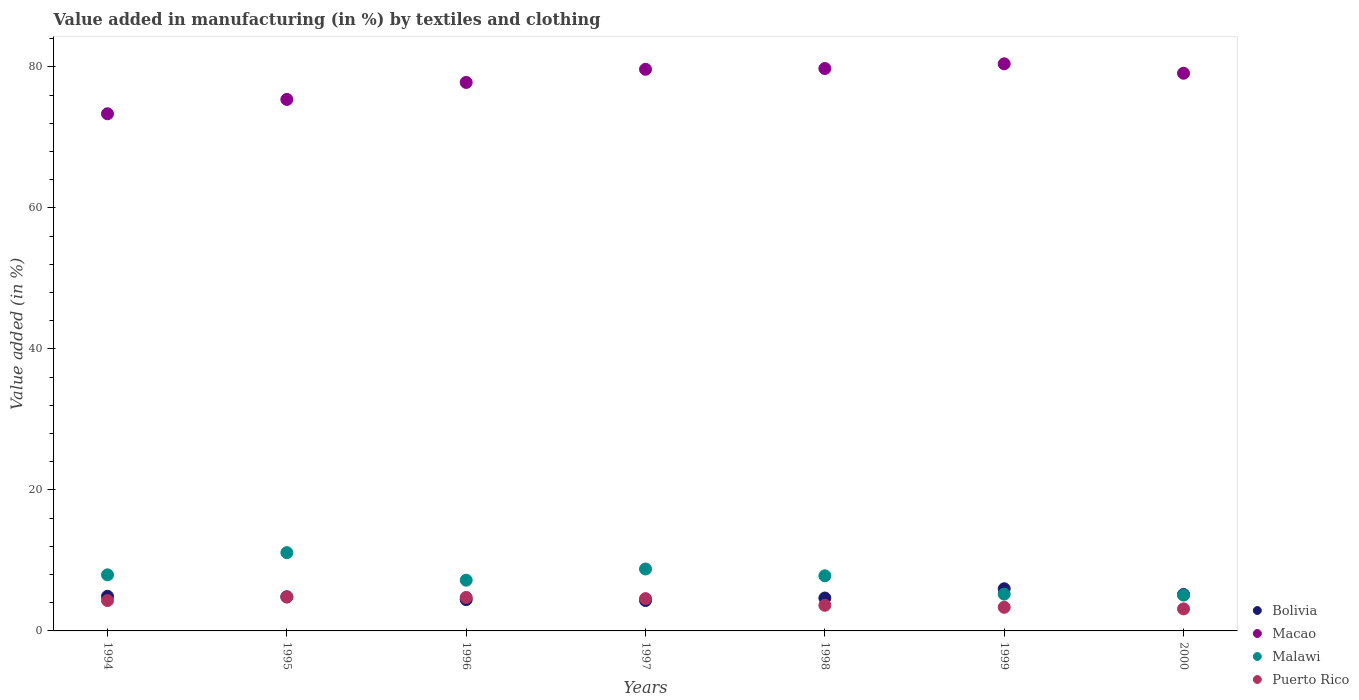How many different coloured dotlines are there?
Give a very brief answer. 4. Is the number of dotlines equal to the number of legend labels?
Provide a succinct answer. Yes. What is the percentage of value added in manufacturing by textiles and clothing in Puerto Rico in 2000?
Ensure brevity in your answer.  3.13. Across all years, what is the maximum percentage of value added in manufacturing by textiles and clothing in Malawi?
Your response must be concise. 11.1. Across all years, what is the minimum percentage of value added in manufacturing by textiles and clothing in Macao?
Your answer should be compact. 73.35. In which year was the percentage of value added in manufacturing by textiles and clothing in Puerto Rico maximum?
Your answer should be compact. 1995. In which year was the percentage of value added in manufacturing by textiles and clothing in Malawi minimum?
Offer a very short reply. 2000. What is the total percentage of value added in manufacturing by textiles and clothing in Malawi in the graph?
Ensure brevity in your answer.  53.15. What is the difference between the percentage of value added in manufacturing by textiles and clothing in Bolivia in 1997 and that in 1998?
Your answer should be very brief. -0.35. What is the difference between the percentage of value added in manufacturing by textiles and clothing in Puerto Rico in 1998 and the percentage of value added in manufacturing by textiles and clothing in Bolivia in 1994?
Ensure brevity in your answer.  -1.27. What is the average percentage of value added in manufacturing by textiles and clothing in Puerto Rico per year?
Offer a terse response. 4.08. In the year 1998, what is the difference between the percentage of value added in manufacturing by textiles and clothing in Puerto Rico and percentage of value added in manufacturing by textiles and clothing in Macao?
Offer a very short reply. -76.14. In how many years, is the percentage of value added in manufacturing by textiles and clothing in Malawi greater than 44 %?
Your answer should be very brief. 0. What is the ratio of the percentage of value added in manufacturing by textiles and clothing in Malawi in 1997 to that in 1998?
Your answer should be compact. 1.12. What is the difference between the highest and the second highest percentage of value added in manufacturing by textiles and clothing in Bolivia?
Offer a terse response. 0.81. What is the difference between the highest and the lowest percentage of value added in manufacturing by textiles and clothing in Macao?
Offer a very short reply. 7.08. In how many years, is the percentage of value added in manufacturing by textiles and clothing in Bolivia greater than the average percentage of value added in manufacturing by textiles and clothing in Bolivia taken over all years?
Give a very brief answer. 3. Is the sum of the percentage of value added in manufacturing by textiles and clothing in Malawi in 1994 and 1998 greater than the maximum percentage of value added in manufacturing by textiles and clothing in Bolivia across all years?
Your response must be concise. Yes. Is the percentage of value added in manufacturing by textiles and clothing in Macao strictly less than the percentage of value added in manufacturing by textiles and clothing in Malawi over the years?
Your response must be concise. No. How many dotlines are there?
Ensure brevity in your answer.  4. Are the values on the major ticks of Y-axis written in scientific E-notation?
Your answer should be very brief. No. How are the legend labels stacked?
Make the answer very short. Vertical. What is the title of the graph?
Your response must be concise. Value added in manufacturing (in %) by textiles and clothing. What is the label or title of the Y-axis?
Your response must be concise. Value added (in %). What is the Value added (in %) in Bolivia in 1994?
Offer a terse response. 4.91. What is the Value added (in %) in Macao in 1994?
Your answer should be very brief. 73.35. What is the Value added (in %) of Malawi in 1994?
Provide a short and direct response. 7.95. What is the Value added (in %) of Puerto Rico in 1994?
Your answer should be compact. 4.31. What is the Value added (in %) of Bolivia in 1995?
Your answer should be compact. 4.84. What is the Value added (in %) in Macao in 1995?
Offer a very short reply. 75.38. What is the Value added (in %) in Malawi in 1995?
Make the answer very short. 11.1. What is the Value added (in %) in Puerto Rico in 1995?
Your answer should be very brief. 4.8. What is the Value added (in %) in Bolivia in 1996?
Provide a succinct answer. 4.44. What is the Value added (in %) in Macao in 1996?
Your response must be concise. 77.8. What is the Value added (in %) in Malawi in 1996?
Offer a terse response. 7.19. What is the Value added (in %) of Puerto Rico in 1996?
Offer a very short reply. 4.75. What is the Value added (in %) of Bolivia in 1997?
Offer a terse response. 4.31. What is the Value added (in %) of Macao in 1997?
Your response must be concise. 79.66. What is the Value added (in %) in Malawi in 1997?
Provide a short and direct response. 8.78. What is the Value added (in %) of Puerto Rico in 1997?
Your response must be concise. 4.58. What is the Value added (in %) in Bolivia in 1998?
Your response must be concise. 4.67. What is the Value added (in %) in Macao in 1998?
Make the answer very short. 79.77. What is the Value added (in %) in Malawi in 1998?
Offer a very short reply. 7.82. What is the Value added (in %) of Puerto Rico in 1998?
Your answer should be compact. 3.63. What is the Value added (in %) in Bolivia in 1999?
Provide a succinct answer. 5.98. What is the Value added (in %) in Macao in 1999?
Provide a succinct answer. 80.43. What is the Value added (in %) in Malawi in 1999?
Offer a terse response. 5.22. What is the Value added (in %) of Puerto Rico in 1999?
Offer a terse response. 3.35. What is the Value added (in %) in Bolivia in 2000?
Keep it short and to the point. 5.17. What is the Value added (in %) of Macao in 2000?
Offer a terse response. 79.1. What is the Value added (in %) of Malawi in 2000?
Offer a terse response. 5.08. What is the Value added (in %) in Puerto Rico in 2000?
Ensure brevity in your answer.  3.13. Across all years, what is the maximum Value added (in %) of Bolivia?
Ensure brevity in your answer.  5.98. Across all years, what is the maximum Value added (in %) of Macao?
Offer a very short reply. 80.43. Across all years, what is the maximum Value added (in %) in Malawi?
Offer a very short reply. 11.1. Across all years, what is the maximum Value added (in %) of Puerto Rico?
Keep it short and to the point. 4.8. Across all years, what is the minimum Value added (in %) of Bolivia?
Provide a succinct answer. 4.31. Across all years, what is the minimum Value added (in %) of Macao?
Make the answer very short. 73.35. Across all years, what is the minimum Value added (in %) in Malawi?
Offer a terse response. 5.08. Across all years, what is the minimum Value added (in %) in Puerto Rico?
Make the answer very short. 3.13. What is the total Value added (in %) of Bolivia in the graph?
Your response must be concise. 34.32. What is the total Value added (in %) in Macao in the graph?
Keep it short and to the point. 545.49. What is the total Value added (in %) of Malawi in the graph?
Your answer should be compact. 53.15. What is the total Value added (in %) of Puerto Rico in the graph?
Ensure brevity in your answer.  28.55. What is the difference between the Value added (in %) of Bolivia in 1994 and that in 1995?
Give a very brief answer. 0.06. What is the difference between the Value added (in %) of Macao in 1994 and that in 1995?
Give a very brief answer. -2.03. What is the difference between the Value added (in %) of Malawi in 1994 and that in 1995?
Keep it short and to the point. -3.15. What is the difference between the Value added (in %) of Puerto Rico in 1994 and that in 1995?
Give a very brief answer. -0.5. What is the difference between the Value added (in %) in Bolivia in 1994 and that in 1996?
Your answer should be compact. 0.47. What is the difference between the Value added (in %) of Macao in 1994 and that in 1996?
Offer a terse response. -4.45. What is the difference between the Value added (in %) in Malawi in 1994 and that in 1996?
Offer a very short reply. 0.76. What is the difference between the Value added (in %) of Puerto Rico in 1994 and that in 1996?
Provide a succinct answer. -0.44. What is the difference between the Value added (in %) of Bolivia in 1994 and that in 1997?
Your answer should be compact. 0.6. What is the difference between the Value added (in %) in Macao in 1994 and that in 1997?
Give a very brief answer. -6.31. What is the difference between the Value added (in %) of Malawi in 1994 and that in 1997?
Offer a very short reply. -0.83. What is the difference between the Value added (in %) of Puerto Rico in 1994 and that in 1997?
Make the answer very short. -0.28. What is the difference between the Value added (in %) in Bolivia in 1994 and that in 1998?
Offer a terse response. 0.24. What is the difference between the Value added (in %) in Macao in 1994 and that in 1998?
Offer a terse response. -6.42. What is the difference between the Value added (in %) in Malawi in 1994 and that in 1998?
Keep it short and to the point. 0.14. What is the difference between the Value added (in %) of Puerto Rico in 1994 and that in 1998?
Your answer should be compact. 0.67. What is the difference between the Value added (in %) of Bolivia in 1994 and that in 1999?
Offer a terse response. -1.07. What is the difference between the Value added (in %) in Macao in 1994 and that in 1999?
Ensure brevity in your answer.  -7.08. What is the difference between the Value added (in %) in Malawi in 1994 and that in 1999?
Make the answer very short. 2.74. What is the difference between the Value added (in %) in Puerto Rico in 1994 and that in 1999?
Offer a terse response. 0.96. What is the difference between the Value added (in %) in Bolivia in 1994 and that in 2000?
Your response must be concise. -0.26. What is the difference between the Value added (in %) of Macao in 1994 and that in 2000?
Your answer should be very brief. -5.75. What is the difference between the Value added (in %) in Malawi in 1994 and that in 2000?
Provide a succinct answer. 2.87. What is the difference between the Value added (in %) in Puerto Rico in 1994 and that in 2000?
Your response must be concise. 1.18. What is the difference between the Value added (in %) in Bolivia in 1995 and that in 1996?
Ensure brevity in your answer.  0.41. What is the difference between the Value added (in %) of Macao in 1995 and that in 1996?
Give a very brief answer. -2.41. What is the difference between the Value added (in %) of Malawi in 1995 and that in 1996?
Offer a very short reply. 3.91. What is the difference between the Value added (in %) in Puerto Rico in 1995 and that in 1996?
Your answer should be very brief. 0.06. What is the difference between the Value added (in %) of Bolivia in 1995 and that in 1997?
Your answer should be compact. 0.53. What is the difference between the Value added (in %) of Macao in 1995 and that in 1997?
Provide a succinct answer. -4.27. What is the difference between the Value added (in %) in Malawi in 1995 and that in 1997?
Provide a succinct answer. 2.32. What is the difference between the Value added (in %) of Puerto Rico in 1995 and that in 1997?
Your answer should be very brief. 0.22. What is the difference between the Value added (in %) in Bolivia in 1995 and that in 1998?
Your answer should be very brief. 0.18. What is the difference between the Value added (in %) of Macao in 1995 and that in 1998?
Ensure brevity in your answer.  -4.39. What is the difference between the Value added (in %) in Malawi in 1995 and that in 1998?
Make the answer very short. 3.28. What is the difference between the Value added (in %) of Puerto Rico in 1995 and that in 1998?
Your answer should be compact. 1.17. What is the difference between the Value added (in %) in Bolivia in 1995 and that in 1999?
Provide a short and direct response. -1.14. What is the difference between the Value added (in %) of Macao in 1995 and that in 1999?
Offer a very short reply. -5.05. What is the difference between the Value added (in %) of Malawi in 1995 and that in 1999?
Your answer should be very brief. 5.88. What is the difference between the Value added (in %) of Puerto Rico in 1995 and that in 1999?
Ensure brevity in your answer.  1.46. What is the difference between the Value added (in %) of Bolivia in 1995 and that in 2000?
Offer a very short reply. -0.33. What is the difference between the Value added (in %) of Macao in 1995 and that in 2000?
Your answer should be very brief. -3.71. What is the difference between the Value added (in %) in Malawi in 1995 and that in 2000?
Provide a short and direct response. 6.02. What is the difference between the Value added (in %) in Puerto Rico in 1995 and that in 2000?
Ensure brevity in your answer.  1.68. What is the difference between the Value added (in %) of Bolivia in 1996 and that in 1997?
Provide a short and direct response. 0.12. What is the difference between the Value added (in %) in Macao in 1996 and that in 1997?
Keep it short and to the point. -1.86. What is the difference between the Value added (in %) in Malawi in 1996 and that in 1997?
Offer a terse response. -1.59. What is the difference between the Value added (in %) in Puerto Rico in 1996 and that in 1997?
Provide a short and direct response. 0.17. What is the difference between the Value added (in %) of Bolivia in 1996 and that in 1998?
Make the answer very short. -0.23. What is the difference between the Value added (in %) in Macao in 1996 and that in 1998?
Make the answer very short. -1.97. What is the difference between the Value added (in %) of Malawi in 1996 and that in 1998?
Your answer should be compact. -0.62. What is the difference between the Value added (in %) in Puerto Rico in 1996 and that in 1998?
Your answer should be very brief. 1.11. What is the difference between the Value added (in %) in Bolivia in 1996 and that in 1999?
Provide a succinct answer. -1.54. What is the difference between the Value added (in %) in Macao in 1996 and that in 1999?
Your answer should be very brief. -2.64. What is the difference between the Value added (in %) in Malawi in 1996 and that in 1999?
Your response must be concise. 1.98. What is the difference between the Value added (in %) of Puerto Rico in 1996 and that in 1999?
Your response must be concise. 1.4. What is the difference between the Value added (in %) in Bolivia in 1996 and that in 2000?
Make the answer very short. -0.74. What is the difference between the Value added (in %) in Macao in 1996 and that in 2000?
Offer a very short reply. -1.3. What is the difference between the Value added (in %) in Malawi in 1996 and that in 2000?
Offer a terse response. 2.11. What is the difference between the Value added (in %) of Puerto Rico in 1996 and that in 2000?
Keep it short and to the point. 1.62. What is the difference between the Value added (in %) of Bolivia in 1997 and that in 1998?
Your answer should be very brief. -0.35. What is the difference between the Value added (in %) of Macao in 1997 and that in 1998?
Give a very brief answer. -0.11. What is the difference between the Value added (in %) of Malawi in 1997 and that in 1998?
Provide a short and direct response. 0.97. What is the difference between the Value added (in %) of Puerto Rico in 1997 and that in 1998?
Offer a terse response. 0.95. What is the difference between the Value added (in %) in Bolivia in 1997 and that in 1999?
Your response must be concise. -1.67. What is the difference between the Value added (in %) of Macao in 1997 and that in 1999?
Provide a succinct answer. -0.78. What is the difference between the Value added (in %) in Malawi in 1997 and that in 1999?
Provide a succinct answer. 3.57. What is the difference between the Value added (in %) of Puerto Rico in 1997 and that in 1999?
Make the answer very short. 1.23. What is the difference between the Value added (in %) in Bolivia in 1997 and that in 2000?
Provide a short and direct response. -0.86. What is the difference between the Value added (in %) in Macao in 1997 and that in 2000?
Ensure brevity in your answer.  0.56. What is the difference between the Value added (in %) in Malawi in 1997 and that in 2000?
Make the answer very short. 3.7. What is the difference between the Value added (in %) in Puerto Rico in 1997 and that in 2000?
Your answer should be compact. 1.46. What is the difference between the Value added (in %) of Bolivia in 1998 and that in 1999?
Your answer should be compact. -1.31. What is the difference between the Value added (in %) of Macao in 1998 and that in 1999?
Make the answer very short. -0.66. What is the difference between the Value added (in %) in Malawi in 1998 and that in 1999?
Ensure brevity in your answer.  2.6. What is the difference between the Value added (in %) of Puerto Rico in 1998 and that in 1999?
Give a very brief answer. 0.28. What is the difference between the Value added (in %) in Bolivia in 1998 and that in 2000?
Offer a very short reply. -0.51. What is the difference between the Value added (in %) in Macao in 1998 and that in 2000?
Provide a short and direct response. 0.67. What is the difference between the Value added (in %) in Malawi in 1998 and that in 2000?
Ensure brevity in your answer.  2.74. What is the difference between the Value added (in %) in Puerto Rico in 1998 and that in 2000?
Your answer should be compact. 0.51. What is the difference between the Value added (in %) in Bolivia in 1999 and that in 2000?
Keep it short and to the point. 0.81. What is the difference between the Value added (in %) in Macao in 1999 and that in 2000?
Offer a terse response. 1.34. What is the difference between the Value added (in %) in Malawi in 1999 and that in 2000?
Your answer should be very brief. 0.14. What is the difference between the Value added (in %) in Puerto Rico in 1999 and that in 2000?
Your answer should be compact. 0.22. What is the difference between the Value added (in %) of Bolivia in 1994 and the Value added (in %) of Macao in 1995?
Provide a short and direct response. -70.48. What is the difference between the Value added (in %) in Bolivia in 1994 and the Value added (in %) in Malawi in 1995?
Ensure brevity in your answer.  -6.19. What is the difference between the Value added (in %) of Bolivia in 1994 and the Value added (in %) of Puerto Rico in 1995?
Your response must be concise. 0.1. What is the difference between the Value added (in %) in Macao in 1994 and the Value added (in %) in Malawi in 1995?
Your answer should be compact. 62.25. What is the difference between the Value added (in %) in Macao in 1994 and the Value added (in %) in Puerto Rico in 1995?
Provide a short and direct response. 68.54. What is the difference between the Value added (in %) in Malawi in 1994 and the Value added (in %) in Puerto Rico in 1995?
Offer a terse response. 3.15. What is the difference between the Value added (in %) of Bolivia in 1994 and the Value added (in %) of Macao in 1996?
Ensure brevity in your answer.  -72.89. What is the difference between the Value added (in %) in Bolivia in 1994 and the Value added (in %) in Malawi in 1996?
Ensure brevity in your answer.  -2.29. What is the difference between the Value added (in %) in Bolivia in 1994 and the Value added (in %) in Puerto Rico in 1996?
Provide a short and direct response. 0.16. What is the difference between the Value added (in %) of Macao in 1994 and the Value added (in %) of Malawi in 1996?
Your answer should be compact. 66.15. What is the difference between the Value added (in %) of Macao in 1994 and the Value added (in %) of Puerto Rico in 1996?
Provide a succinct answer. 68.6. What is the difference between the Value added (in %) of Malawi in 1994 and the Value added (in %) of Puerto Rico in 1996?
Make the answer very short. 3.21. What is the difference between the Value added (in %) in Bolivia in 1994 and the Value added (in %) in Macao in 1997?
Offer a very short reply. -74.75. What is the difference between the Value added (in %) in Bolivia in 1994 and the Value added (in %) in Malawi in 1997?
Your answer should be very brief. -3.88. What is the difference between the Value added (in %) in Bolivia in 1994 and the Value added (in %) in Puerto Rico in 1997?
Keep it short and to the point. 0.33. What is the difference between the Value added (in %) in Macao in 1994 and the Value added (in %) in Malawi in 1997?
Provide a short and direct response. 64.57. What is the difference between the Value added (in %) in Macao in 1994 and the Value added (in %) in Puerto Rico in 1997?
Your answer should be very brief. 68.77. What is the difference between the Value added (in %) of Malawi in 1994 and the Value added (in %) of Puerto Rico in 1997?
Provide a short and direct response. 3.37. What is the difference between the Value added (in %) in Bolivia in 1994 and the Value added (in %) in Macao in 1998?
Ensure brevity in your answer.  -74.86. What is the difference between the Value added (in %) in Bolivia in 1994 and the Value added (in %) in Malawi in 1998?
Your answer should be compact. -2.91. What is the difference between the Value added (in %) in Bolivia in 1994 and the Value added (in %) in Puerto Rico in 1998?
Provide a succinct answer. 1.27. What is the difference between the Value added (in %) in Macao in 1994 and the Value added (in %) in Malawi in 1998?
Make the answer very short. 65.53. What is the difference between the Value added (in %) of Macao in 1994 and the Value added (in %) of Puerto Rico in 1998?
Provide a succinct answer. 69.71. What is the difference between the Value added (in %) of Malawi in 1994 and the Value added (in %) of Puerto Rico in 1998?
Your response must be concise. 4.32. What is the difference between the Value added (in %) in Bolivia in 1994 and the Value added (in %) in Macao in 1999?
Provide a short and direct response. -75.53. What is the difference between the Value added (in %) of Bolivia in 1994 and the Value added (in %) of Malawi in 1999?
Offer a terse response. -0.31. What is the difference between the Value added (in %) in Bolivia in 1994 and the Value added (in %) in Puerto Rico in 1999?
Give a very brief answer. 1.56. What is the difference between the Value added (in %) in Macao in 1994 and the Value added (in %) in Malawi in 1999?
Your response must be concise. 68.13. What is the difference between the Value added (in %) of Macao in 1994 and the Value added (in %) of Puerto Rico in 1999?
Provide a short and direct response. 70. What is the difference between the Value added (in %) of Malawi in 1994 and the Value added (in %) of Puerto Rico in 1999?
Your answer should be very brief. 4.61. What is the difference between the Value added (in %) in Bolivia in 1994 and the Value added (in %) in Macao in 2000?
Keep it short and to the point. -74.19. What is the difference between the Value added (in %) of Bolivia in 1994 and the Value added (in %) of Malawi in 2000?
Offer a terse response. -0.17. What is the difference between the Value added (in %) in Bolivia in 1994 and the Value added (in %) in Puerto Rico in 2000?
Provide a succinct answer. 1.78. What is the difference between the Value added (in %) of Macao in 1994 and the Value added (in %) of Malawi in 2000?
Your answer should be compact. 68.27. What is the difference between the Value added (in %) of Macao in 1994 and the Value added (in %) of Puerto Rico in 2000?
Give a very brief answer. 70.22. What is the difference between the Value added (in %) in Malawi in 1994 and the Value added (in %) in Puerto Rico in 2000?
Your response must be concise. 4.83. What is the difference between the Value added (in %) of Bolivia in 1995 and the Value added (in %) of Macao in 1996?
Offer a very short reply. -72.95. What is the difference between the Value added (in %) of Bolivia in 1995 and the Value added (in %) of Malawi in 1996?
Provide a short and direct response. -2.35. What is the difference between the Value added (in %) in Bolivia in 1995 and the Value added (in %) in Puerto Rico in 1996?
Your answer should be very brief. 0.09. What is the difference between the Value added (in %) of Macao in 1995 and the Value added (in %) of Malawi in 1996?
Your response must be concise. 68.19. What is the difference between the Value added (in %) of Macao in 1995 and the Value added (in %) of Puerto Rico in 1996?
Offer a very short reply. 70.64. What is the difference between the Value added (in %) of Malawi in 1995 and the Value added (in %) of Puerto Rico in 1996?
Offer a very short reply. 6.35. What is the difference between the Value added (in %) of Bolivia in 1995 and the Value added (in %) of Macao in 1997?
Make the answer very short. -74.82. What is the difference between the Value added (in %) of Bolivia in 1995 and the Value added (in %) of Malawi in 1997?
Your response must be concise. -3.94. What is the difference between the Value added (in %) of Bolivia in 1995 and the Value added (in %) of Puerto Rico in 1997?
Your response must be concise. 0.26. What is the difference between the Value added (in %) in Macao in 1995 and the Value added (in %) in Malawi in 1997?
Offer a terse response. 66.6. What is the difference between the Value added (in %) in Macao in 1995 and the Value added (in %) in Puerto Rico in 1997?
Provide a short and direct response. 70.8. What is the difference between the Value added (in %) in Malawi in 1995 and the Value added (in %) in Puerto Rico in 1997?
Ensure brevity in your answer.  6.52. What is the difference between the Value added (in %) in Bolivia in 1995 and the Value added (in %) in Macao in 1998?
Your answer should be very brief. -74.93. What is the difference between the Value added (in %) in Bolivia in 1995 and the Value added (in %) in Malawi in 1998?
Your answer should be compact. -2.97. What is the difference between the Value added (in %) in Bolivia in 1995 and the Value added (in %) in Puerto Rico in 1998?
Offer a very short reply. 1.21. What is the difference between the Value added (in %) in Macao in 1995 and the Value added (in %) in Malawi in 1998?
Ensure brevity in your answer.  67.57. What is the difference between the Value added (in %) of Macao in 1995 and the Value added (in %) of Puerto Rico in 1998?
Make the answer very short. 71.75. What is the difference between the Value added (in %) in Malawi in 1995 and the Value added (in %) in Puerto Rico in 1998?
Your answer should be compact. 7.47. What is the difference between the Value added (in %) in Bolivia in 1995 and the Value added (in %) in Macao in 1999?
Your response must be concise. -75.59. What is the difference between the Value added (in %) of Bolivia in 1995 and the Value added (in %) of Malawi in 1999?
Make the answer very short. -0.37. What is the difference between the Value added (in %) in Bolivia in 1995 and the Value added (in %) in Puerto Rico in 1999?
Provide a succinct answer. 1.49. What is the difference between the Value added (in %) of Macao in 1995 and the Value added (in %) of Malawi in 1999?
Your answer should be very brief. 70.17. What is the difference between the Value added (in %) in Macao in 1995 and the Value added (in %) in Puerto Rico in 1999?
Offer a very short reply. 72.03. What is the difference between the Value added (in %) of Malawi in 1995 and the Value added (in %) of Puerto Rico in 1999?
Your answer should be very brief. 7.75. What is the difference between the Value added (in %) in Bolivia in 1995 and the Value added (in %) in Macao in 2000?
Offer a very short reply. -74.26. What is the difference between the Value added (in %) in Bolivia in 1995 and the Value added (in %) in Malawi in 2000?
Make the answer very short. -0.24. What is the difference between the Value added (in %) in Bolivia in 1995 and the Value added (in %) in Puerto Rico in 2000?
Provide a succinct answer. 1.72. What is the difference between the Value added (in %) in Macao in 1995 and the Value added (in %) in Malawi in 2000?
Ensure brevity in your answer.  70.3. What is the difference between the Value added (in %) of Macao in 1995 and the Value added (in %) of Puerto Rico in 2000?
Keep it short and to the point. 72.26. What is the difference between the Value added (in %) of Malawi in 1995 and the Value added (in %) of Puerto Rico in 2000?
Your answer should be very brief. 7.98. What is the difference between the Value added (in %) of Bolivia in 1996 and the Value added (in %) of Macao in 1997?
Ensure brevity in your answer.  -75.22. What is the difference between the Value added (in %) of Bolivia in 1996 and the Value added (in %) of Malawi in 1997?
Your response must be concise. -4.35. What is the difference between the Value added (in %) of Bolivia in 1996 and the Value added (in %) of Puerto Rico in 1997?
Give a very brief answer. -0.14. What is the difference between the Value added (in %) in Macao in 1996 and the Value added (in %) in Malawi in 1997?
Keep it short and to the point. 69.01. What is the difference between the Value added (in %) in Macao in 1996 and the Value added (in %) in Puerto Rico in 1997?
Your answer should be very brief. 73.21. What is the difference between the Value added (in %) of Malawi in 1996 and the Value added (in %) of Puerto Rico in 1997?
Ensure brevity in your answer.  2.61. What is the difference between the Value added (in %) in Bolivia in 1996 and the Value added (in %) in Macao in 1998?
Keep it short and to the point. -75.33. What is the difference between the Value added (in %) in Bolivia in 1996 and the Value added (in %) in Malawi in 1998?
Provide a succinct answer. -3.38. What is the difference between the Value added (in %) in Bolivia in 1996 and the Value added (in %) in Puerto Rico in 1998?
Make the answer very short. 0.8. What is the difference between the Value added (in %) in Macao in 1996 and the Value added (in %) in Malawi in 1998?
Offer a terse response. 69.98. What is the difference between the Value added (in %) in Macao in 1996 and the Value added (in %) in Puerto Rico in 1998?
Make the answer very short. 74.16. What is the difference between the Value added (in %) in Malawi in 1996 and the Value added (in %) in Puerto Rico in 1998?
Offer a very short reply. 3.56. What is the difference between the Value added (in %) of Bolivia in 1996 and the Value added (in %) of Macao in 1999?
Offer a very short reply. -76. What is the difference between the Value added (in %) in Bolivia in 1996 and the Value added (in %) in Malawi in 1999?
Make the answer very short. -0.78. What is the difference between the Value added (in %) of Bolivia in 1996 and the Value added (in %) of Puerto Rico in 1999?
Offer a terse response. 1.09. What is the difference between the Value added (in %) of Macao in 1996 and the Value added (in %) of Malawi in 1999?
Offer a terse response. 72.58. What is the difference between the Value added (in %) of Macao in 1996 and the Value added (in %) of Puerto Rico in 1999?
Make the answer very short. 74.45. What is the difference between the Value added (in %) of Malawi in 1996 and the Value added (in %) of Puerto Rico in 1999?
Ensure brevity in your answer.  3.85. What is the difference between the Value added (in %) in Bolivia in 1996 and the Value added (in %) in Macao in 2000?
Your response must be concise. -74.66. What is the difference between the Value added (in %) of Bolivia in 1996 and the Value added (in %) of Malawi in 2000?
Your answer should be very brief. -0.64. What is the difference between the Value added (in %) in Bolivia in 1996 and the Value added (in %) in Puerto Rico in 2000?
Give a very brief answer. 1.31. What is the difference between the Value added (in %) of Macao in 1996 and the Value added (in %) of Malawi in 2000?
Provide a short and direct response. 72.71. What is the difference between the Value added (in %) in Macao in 1996 and the Value added (in %) in Puerto Rico in 2000?
Provide a short and direct response. 74.67. What is the difference between the Value added (in %) in Malawi in 1996 and the Value added (in %) in Puerto Rico in 2000?
Ensure brevity in your answer.  4.07. What is the difference between the Value added (in %) in Bolivia in 1997 and the Value added (in %) in Macao in 1998?
Offer a very short reply. -75.46. What is the difference between the Value added (in %) in Bolivia in 1997 and the Value added (in %) in Malawi in 1998?
Your response must be concise. -3.51. What is the difference between the Value added (in %) in Bolivia in 1997 and the Value added (in %) in Puerto Rico in 1998?
Offer a very short reply. 0.68. What is the difference between the Value added (in %) in Macao in 1997 and the Value added (in %) in Malawi in 1998?
Give a very brief answer. 71.84. What is the difference between the Value added (in %) of Macao in 1997 and the Value added (in %) of Puerto Rico in 1998?
Make the answer very short. 76.02. What is the difference between the Value added (in %) of Malawi in 1997 and the Value added (in %) of Puerto Rico in 1998?
Your answer should be very brief. 5.15. What is the difference between the Value added (in %) in Bolivia in 1997 and the Value added (in %) in Macao in 1999?
Offer a terse response. -76.12. What is the difference between the Value added (in %) of Bolivia in 1997 and the Value added (in %) of Malawi in 1999?
Offer a terse response. -0.91. What is the difference between the Value added (in %) in Bolivia in 1997 and the Value added (in %) in Puerto Rico in 1999?
Ensure brevity in your answer.  0.96. What is the difference between the Value added (in %) of Macao in 1997 and the Value added (in %) of Malawi in 1999?
Provide a succinct answer. 74.44. What is the difference between the Value added (in %) in Macao in 1997 and the Value added (in %) in Puerto Rico in 1999?
Your response must be concise. 76.31. What is the difference between the Value added (in %) in Malawi in 1997 and the Value added (in %) in Puerto Rico in 1999?
Your answer should be very brief. 5.43. What is the difference between the Value added (in %) of Bolivia in 1997 and the Value added (in %) of Macao in 2000?
Ensure brevity in your answer.  -74.79. What is the difference between the Value added (in %) in Bolivia in 1997 and the Value added (in %) in Malawi in 2000?
Provide a short and direct response. -0.77. What is the difference between the Value added (in %) of Bolivia in 1997 and the Value added (in %) of Puerto Rico in 2000?
Your answer should be very brief. 1.19. What is the difference between the Value added (in %) of Macao in 1997 and the Value added (in %) of Malawi in 2000?
Make the answer very short. 74.58. What is the difference between the Value added (in %) in Macao in 1997 and the Value added (in %) in Puerto Rico in 2000?
Offer a very short reply. 76.53. What is the difference between the Value added (in %) of Malawi in 1997 and the Value added (in %) of Puerto Rico in 2000?
Your answer should be compact. 5.66. What is the difference between the Value added (in %) of Bolivia in 1998 and the Value added (in %) of Macao in 1999?
Keep it short and to the point. -75.77. What is the difference between the Value added (in %) of Bolivia in 1998 and the Value added (in %) of Malawi in 1999?
Make the answer very short. -0.55. What is the difference between the Value added (in %) of Bolivia in 1998 and the Value added (in %) of Puerto Rico in 1999?
Provide a short and direct response. 1.32. What is the difference between the Value added (in %) of Macao in 1998 and the Value added (in %) of Malawi in 1999?
Give a very brief answer. 74.55. What is the difference between the Value added (in %) of Macao in 1998 and the Value added (in %) of Puerto Rico in 1999?
Keep it short and to the point. 76.42. What is the difference between the Value added (in %) in Malawi in 1998 and the Value added (in %) in Puerto Rico in 1999?
Your answer should be compact. 4.47. What is the difference between the Value added (in %) in Bolivia in 1998 and the Value added (in %) in Macao in 2000?
Offer a very short reply. -74.43. What is the difference between the Value added (in %) in Bolivia in 1998 and the Value added (in %) in Malawi in 2000?
Ensure brevity in your answer.  -0.42. What is the difference between the Value added (in %) in Bolivia in 1998 and the Value added (in %) in Puerto Rico in 2000?
Your answer should be very brief. 1.54. What is the difference between the Value added (in %) of Macao in 1998 and the Value added (in %) of Malawi in 2000?
Provide a succinct answer. 74.69. What is the difference between the Value added (in %) of Macao in 1998 and the Value added (in %) of Puerto Rico in 2000?
Offer a terse response. 76.64. What is the difference between the Value added (in %) of Malawi in 1998 and the Value added (in %) of Puerto Rico in 2000?
Your answer should be compact. 4.69. What is the difference between the Value added (in %) of Bolivia in 1999 and the Value added (in %) of Macao in 2000?
Offer a very short reply. -73.12. What is the difference between the Value added (in %) in Bolivia in 1999 and the Value added (in %) in Malawi in 2000?
Provide a succinct answer. 0.9. What is the difference between the Value added (in %) in Bolivia in 1999 and the Value added (in %) in Puerto Rico in 2000?
Offer a terse response. 2.85. What is the difference between the Value added (in %) in Macao in 1999 and the Value added (in %) in Malawi in 2000?
Your answer should be very brief. 75.35. What is the difference between the Value added (in %) of Macao in 1999 and the Value added (in %) of Puerto Rico in 2000?
Keep it short and to the point. 77.31. What is the difference between the Value added (in %) in Malawi in 1999 and the Value added (in %) in Puerto Rico in 2000?
Provide a short and direct response. 2.09. What is the average Value added (in %) of Bolivia per year?
Keep it short and to the point. 4.9. What is the average Value added (in %) in Macao per year?
Keep it short and to the point. 77.93. What is the average Value added (in %) of Malawi per year?
Offer a very short reply. 7.59. What is the average Value added (in %) of Puerto Rico per year?
Make the answer very short. 4.08. In the year 1994, what is the difference between the Value added (in %) in Bolivia and Value added (in %) in Macao?
Provide a succinct answer. -68.44. In the year 1994, what is the difference between the Value added (in %) of Bolivia and Value added (in %) of Malawi?
Give a very brief answer. -3.05. In the year 1994, what is the difference between the Value added (in %) of Bolivia and Value added (in %) of Puerto Rico?
Ensure brevity in your answer.  0.6. In the year 1994, what is the difference between the Value added (in %) in Macao and Value added (in %) in Malawi?
Your answer should be compact. 65.39. In the year 1994, what is the difference between the Value added (in %) in Macao and Value added (in %) in Puerto Rico?
Ensure brevity in your answer.  69.04. In the year 1994, what is the difference between the Value added (in %) in Malawi and Value added (in %) in Puerto Rico?
Provide a succinct answer. 3.65. In the year 1995, what is the difference between the Value added (in %) in Bolivia and Value added (in %) in Macao?
Offer a very short reply. -70.54. In the year 1995, what is the difference between the Value added (in %) of Bolivia and Value added (in %) of Malawi?
Offer a very short reply. -6.26. In the year 1995, what is the difference between the Value added (in %) in Bolivia and Value added (in %) in Puerto Rico?
Provide a succinct answer. 0.04. In the year 1995, what is the difference between the Value added (in %) of Macao and Value added (in %) of Malawi?
Provide a succinct answer. 64.28. In the year 1995, what is the difference between the Value added (in %) in Macao and Value added (in %) in Puerto Rico?
Keep it short and to the point. 70.58. In the year 1995, what is the difference between the Value added (in %) in Malawi and Value added (in %) in Puerto Rico?
Offer a terse response. 6.3. In the year 1996, what is the difference between the Value added (in %) in Bolivia and Value added (in %) in Macao?
Keep it short and to the point. -73.36. In the year 1996, what is the difference between the Value added (in %) in Bolivia and Value added (in %) in Malawi?
Give a very brief answer. -2.76. In the year 1996, what is the difference between the Value added (in %) of Bolivia and Value added (in %) of Puerto Rico?
Provide a succinct answer. -0.31. In the year 1996, what is the difference between the Value added (in %) in Macao and Value added (in %) in Malawi?
Your answer should be very brief. 70.6. In the year 1996, what is the difference between the Value added (in %) of Macao and Value added (in %) of Puerto Rico?
Provide a succinct answer. 73.05. In the year 1996, what is the difference between the Value added (in %) in Malawi and Value added (in %) in Puerto Rico?
Keep it short and to the point. 2.45. In the year 1997, what is the difference between the Value added (in %) in Bolivia and Value added (in %) in Macao?
Offer a very short reply. -75.35. In the year 1997, what is the difference between the Value added (in %) of Bolivia and Value added (in %) of Malawi?
Provide a short and direct response. -4.47. In the year 1997, what is the difference between the Value added (in %) in Bolivia and Value added (in %) in Puerto Rico?
Offer a very short reply. -0.27. In the year 1997, what is the difference between the Value added (in %) of Macao and Value added (in %) of Malawi?
Make the answer very short. 70.88. In the year 1997, what is the difference between the Value added (in %) in Macao and Value added (in %) in Puerto Rico?
Ensure brevity in your answer.  75.08. In the year 1997, what is the difference between the Value added (in %) of Malawi and Value added (in %) of Puerto Rico?
Keep it short and to the point. 4.2. In the year 1998, what is the difference between the Value added (in %) of Bolivia and Value added (in %) of Macao?
Offer a terse response. -75.1. In the year 1998, what is the difference between the Value added (in %) of Bolivia and Value added (in %) of Malawi?
Offer a terse response. -3.15. In the year 1998, what is the difference between the Value added (in %) of Bolivia and Value added (in %) of Puerto Rico?
Provide a succinct answer. 1.03. In the year 1998, what is the difference between the Value added (in %) of Macao and Value added (in %) of Malawi?
Provide a succinct answer. 71.95. In the year 1998, what is the difference between the Value added (in %) in Macao and Value added (in %) in Puerto Rico?
Your answer should be very brief. 76.14. In the year 1998, what is the difference between the Value added (in %) in Malawi and Value added (in %) in Puerto Rico?
Your response must be concise. 4.18. In the year 1999, what is the difference between the Value added (in %) in Bolivia and Value added (in %) in Macao?
Keep it short and to the point. -74.45. In the year 1999, what is the difference between the Value added (in %) of Bolivia and Value added (in %) of Malawi?
Provide a short and direct response. 0.76. In the year 1999, what is the difference between the Value added (in %) in Bolivia and Value added (in %) in Puerto Rico?
Your answer should be compact. 2.63. In the year 1999, what is the difference between the Value added (in %) in Macao and Value added (in %) in Malawi?
Your answer should be very brief. 75.22. In the year 1999, what is the difference between the Value added (in %) in Macao and Value added (in %) in Puerto Rico?
Provide a succinct answer. 77.08. In the year 1999, what is the difference between the Value added (in %) of Malawi and Value added (in %) of Puerto Rico?
Make the answer very short. 1.87. In the year 2000, what is the difference between the Value added (in %) of Bolivia and Value added (in %) of Macao?
Make the answer very short. -73.93. In the year 2000, what is the difference between the Value added (in %) in Bolivia and Value added (in %) in Malawi?
Your answer should be compact. 0.09. In the year 2000, what is the difference between the Value added (in %) in Bolivia and Value added (in %) in Puerto Rico?
Offer a terse response. 2.05. In the year 2000, what is the difference between the Value added (in %) of Macao and Value added (in %) of Malawi?
Give a very brief answer. 74.02. In the year 2000, what is the difference between the Value added (in %) of Macao and Value added (in %) of Puerto Rico?
Provide a short and direct response. 75.97. In the year 2000, what is the difference between the Value added (in %) of Malawi and Value added (in %) of Puerto Rico?
Offer a terse response. 1.95. What is the ratio of the Value added (in %) in Bolivia in 1994 to that in 1995?
Give a very brief answer. 1.01. What is the ratio of the Value added (in %) of Macao in 1994 to that in 1995?
Your answer should be compact. 0.97. What is the ratio of the Value added (in %) of Malawi in 1994 to that in 1995?
Offer a very short reply. 0.72. What is the ratio of the Value added (in %) in Puerto Rico in 1994 to that in 1995?
Your answer should be compact. 0.9. What is the ratio of the Value added (in %) in Bolivia in 1994 to that in 1996?
Keep it short and to the point. 1.11. What is the ratio of the Value added (in %) in Macao in 1994 to that in 1996?
Provide a succinct answer. 0.94. What is the ratio of the Value added (in %) in Malawi in 1994 to that in 1996?
Provide a succinct answer. 1.11. What is the ratio of the Value added (in %) of Puerto Rico in 1994 to that in 1996?
Provide a succinct answer. 0.91. What is the ratio of the Value added (in %) in Bolivia in 1994 to that in 1997?
Your answer should be very brief. 1.14. What is the ratio of the Value added (in %) of Macao in 1994 to that in 1997?
Give a very brief answer. 0.92. What is the ratio of the Value added (in %) in Malawi in 1994 to that in 1997?
Keep it short and to the point. 0.91. What is the ratio of the Value added (in %) of Puerto Rico in 1994 to that in 1997?
Your response must be concise. 0.94. What is the ratio of the Value added (in %) of Bolivia in 1994 to that in 1998?
Provide a succinct answer. 1.05. What is the ratio of the Value added (in %) of Macao in 1994 to that in 1998?
Offer a very short reply. 0.92. What is the ratio of the Value added (in %) of Malawi in 1994 to that in 1998?
Keep it short and to the point. 1.02. What is the ratio of the Value added (in %) of Puerto Rico in 1994 to that in 1998?
Keep it short and to the point. 1.18. What is the ratio of the Value added (in %) of Bolivia in 1994 to that in 1999?
Ensure brevity in your answer.  0.82. What is the ratio of the Value added (in %) of Macao in 1994 to that in 1999?
Ensure brevity in your answer.  0.91. What is the ratio of the Value added (in %) in Malawi in 1994 to that in 1999?
Make the answer very short. 1.52. What is the ratio of the Value added (in %) in Puerto Rico in 1994 to that in 1999?
Offer a terse response. 1.29. What is the ratio of the Value added (in %) of Bolivia in 1994 to that in 2000?
Give a very brief answer. 0.95. What is the ratio of the Value added (in %) of Macao in 1994 to that in 2000?
Your answer should be compact. 0.93. What is the ratio of the Value added (in %) in Malawi in 1994 to that in 2000?
Offer a very short reply. 1.57. What is the ratio of the Value added (in %) of Puerto Rico in 1994 to that in 2000?
Ensure brevity in your answer.  1.38. What is the ratio of the Value added (in %) of Bolivia in 1995 to that in 1996?
Your answer should be very brief. 1.09. What is the ratio of the Value added (in %) of Malawi in 1995 to that in 1996?
Provide a short and direct response. 1.54. What is the ratio of the Value added (in %) in Puerto Rico in 1995 to that in 1996?
Provide a succinct answer. 1.01. What is the ratio of the Value added (in %) of Bolivia in 1995 to that in 1997?
Your response must be concise. 1.12. What is the ratio of the Value added (in %) of Macao in 1995 to that in 1997?
Ensure brevity in your answer.  0.95. What is the ratio of the Value added (in %) in Malawi in 1995 to that in 1997?
Offer a very short reply. 1.26. What is the ratio of the Value added (in %) of Puerto Rico in 1995 to that in 1997?
Your answer should be very brief. 1.05. What is the ratio of the Value added (in %) in Bolivia in 1995 to that in 1998?
Your answer should be very brief. 1.04. What is the ratio of the Value added (in %) in Macao in 1995 to that in 1998?
Make the answer very short. 0.94. What is the ratio of the Value added (in %) of Malawi in 1995 to that in 1998?
Offer a terse response. 1.42. What is the ratio of the Value added (in %) in Puerto Rico in 1995 to that in 1998?
Keep it short and to the point. 1.32. What is the ratio of the Value added (in %) of Bolivia in 1995 to that in 1999?
Your answer should be very brief. 0.81. What is the ratio of the Value added (in %) in Macao in 1995 to that in 1999?
Provide a short and direct response. 0.94. What is the ratio of the Value added (in %) in Malawi in 1995 to that in 1999?
Offer a terse response. 2.13. What is the ratio of the Value added (in %) in Puerto Rico in 1995 to that in 1999?
Your answer should be compact. 1.43. What is the ratio of the Value added (in %) of Bolivia in 1995 to that in 2000?
Your response must be concise. 0.94. What is the ratio of the Value added (in %) in Macao in 1995 to that in 2000?
Your answer should be compact. 0.95. What is the ratio of the Value added (in %) in Malawi in 1995 to that in 2000?
Your answer should be compact. 2.18. What is the ratio of the Value added (in %) of Puerto Rico in 1995 to that in 2000?
Your answer should be very brief. 1.54. What is the ratio of the Value added (in %) of Bolivia in 1996 to that in 1997?
Keep it short and to the point. 1.03. What is the ratio of the Value added (in %) in Macao in 1996 to that in 1997?
Ensure brevity in your answer.  0.98. What is the ratio of the Value added (in %) in Malawi in 1996 to that in 1997?
Your response must be concise. 0.82. What is the ratio of the Value added (in %) in Puerto Rico in 1996 to that in 1997?
Your response must be concise. 1.04. What is the ratio of the Value added (in %) of Bolivia in 1996 to that in 1998?
Offer a terse response. 0.95. What is the ratio of the Value added (in %) in Macao in 1996 to that in 1998?
Ensure brevity in your answer.  0.98. What is the ratio of the Value added (in %) of Malawi in 1996 to that in 1998?
Keep it short and to the point. 0.92. What is the ratio of the Value added (in %) of Puerto Rico in 1996 to that in 1998?
Keep it short and to the point. 1.31. What is the ratio of the Value added (in %) of Bolivia in 1996 to that in 1999?
Offer a terse response. 0.74. What is the ratio of the Value added (in %) of Macao in 1996 to that in 1999?
Provide a short and direct response. 0.97. What is the ratio of the Value added (in %) in Malawi in 1996 to that in 1999?
Offer a terse response. 1.38. What is the ratio of the Value added (in %) of Puerto Rico in 1996 to that in 1999?
Offer a very short reply. 1.42. What is the ratio of the Value added (in %) of Bolivia in 1996 to that in 2000?
Make the answer very short. 0.86. What is the ratio of the Value added (in %) in Macao in 1996 to that in 2000?
Your answer should be compact. 0.98. What is the ratio of the Value added (in %) in Malawi in 1996 to that in 2000?
Make the answer very short. 1.42. What is the ratio of the Value added (in %) of Puerto Rico in 1996 to that in 2000?
Provide a succinct answer. 1.52. What is the ratio of the Value added (in %) of Bolivia in 1997 to that in 1998?
Keep it short and to the point. 0.92. What is the ratio of the Value added (in %) in Malawi in 1997 to that in 1998?
Your response must be concise. 1.12. What is the ratio of the Value added (in %) in Puerto Rico in 1997 to that in 1998?
Provide a short and direct response. 1.26. What is the ratio of the Value added (in %) of Bolivia in 1997 to that in 1999?
Keep it short and to the point. 0.72. What is the ratio of the Value added (in %) of Macao in 1997 to that in 1999?
Provide a short and direct response. 0.99. What is the ratio of the Value added (in %) in Malawi in 1997 to that in 1999?
Make the answer very short. 1.68. What is the ratio of the Value added (in %) in Puerto Rico in 1997 to that in 1999?
Your answer should be compact. 1.37. What is the ratio of the Value added (in %) of Bolivia in 1997 to that in 2000?
Your answer should be compact. 0.83. What is the ratio of the Value added (in %) in Macao in 1997 to that in 2000?
Provide a short and direct response. 1.01. What is the ratio of the Value added (in %) in Malawi in 1997 to that in 2000?
Your response must be concise. 1.73. What is the ratio of the Value added (in %) in Puerto Rico in 1997 to that in 2000?
Provide a succinct answer. 1.47. What is the ratio of the Value added (in %) in Bolivia in 1998 to that in 1999?
Ensure brevity in your answer.  0.78. What is the ratio of the Value added (in %) in Malawi in 1998 to that in 1999?
Offer a very short reply. 1.5. What is the ratio of the Value added (in %) of Puerto Rico in 1998 to that in 1999?
Your response must be concise. 1.09. What is the ratio of the Value added (in %) of Bolivia in 1998 to that in 2000?
Your response must be concise. 0.9. What is the ratio of the Value added (in %) of Macao in 1998 to that in 2000?
Keep it short and to the point. 1.01. What is the ratio of the Value added (in %) in Malawi in 1998 to that in 2000?
Your answer should be compact. 1.54. What is the ratio of the Value added (in %) in Puerto Rico in 1998 to that in 2000?
Ensure brevity in your answer.  1.16. What is the ratio of the Value added (in %) in Bolivia in 1999 to that in 2000?
Your response must be concise. 1.16. What is the ratio of the Value added (in %) in Macao in 1999 to that in 2000?
Provide a short and direct response. 1.02. What is the ratio of the Value added (in %) in Malawi in 1999 to that in 2000?
Keep it short and to the point. 1.03. What is the ratio of the Value added (in %) of Puerto Rico in 1999 to that in 2000?
Your answer should be compact. 1.07. What is the difference between the highest and the second highest Value added (in %) of Bolivia?
Offer a very short reply. 0.81. What is the difference between the highest and the second highest Value added (in %) of Macao?
Provide a short and direct response. 0.66. What is the difference between the highest and the second highest Value added (in %) in Malawi?
Ensure brevity in your answer.  2.32. What is the difference between the highest and the second highest Value added (in %) in Puerto Rico?
Your answer should be compact. 0.06. What is the difference between the highest and the lowest Value added (in %) of Bolivia?
Your answer should be very brief. 1.67. What is the difference between the highest and the lowest Value added (in %) of Macao?
Your response must be concise. 7.08. What is the difference between the highest and the lowest Value added (in %) in Malawi?
Offer a very short reply. 6.02. What is the difference between the highest and the lowest Value added (in %) in Puerto Rico?
Offer a very short reply. 1.68. 